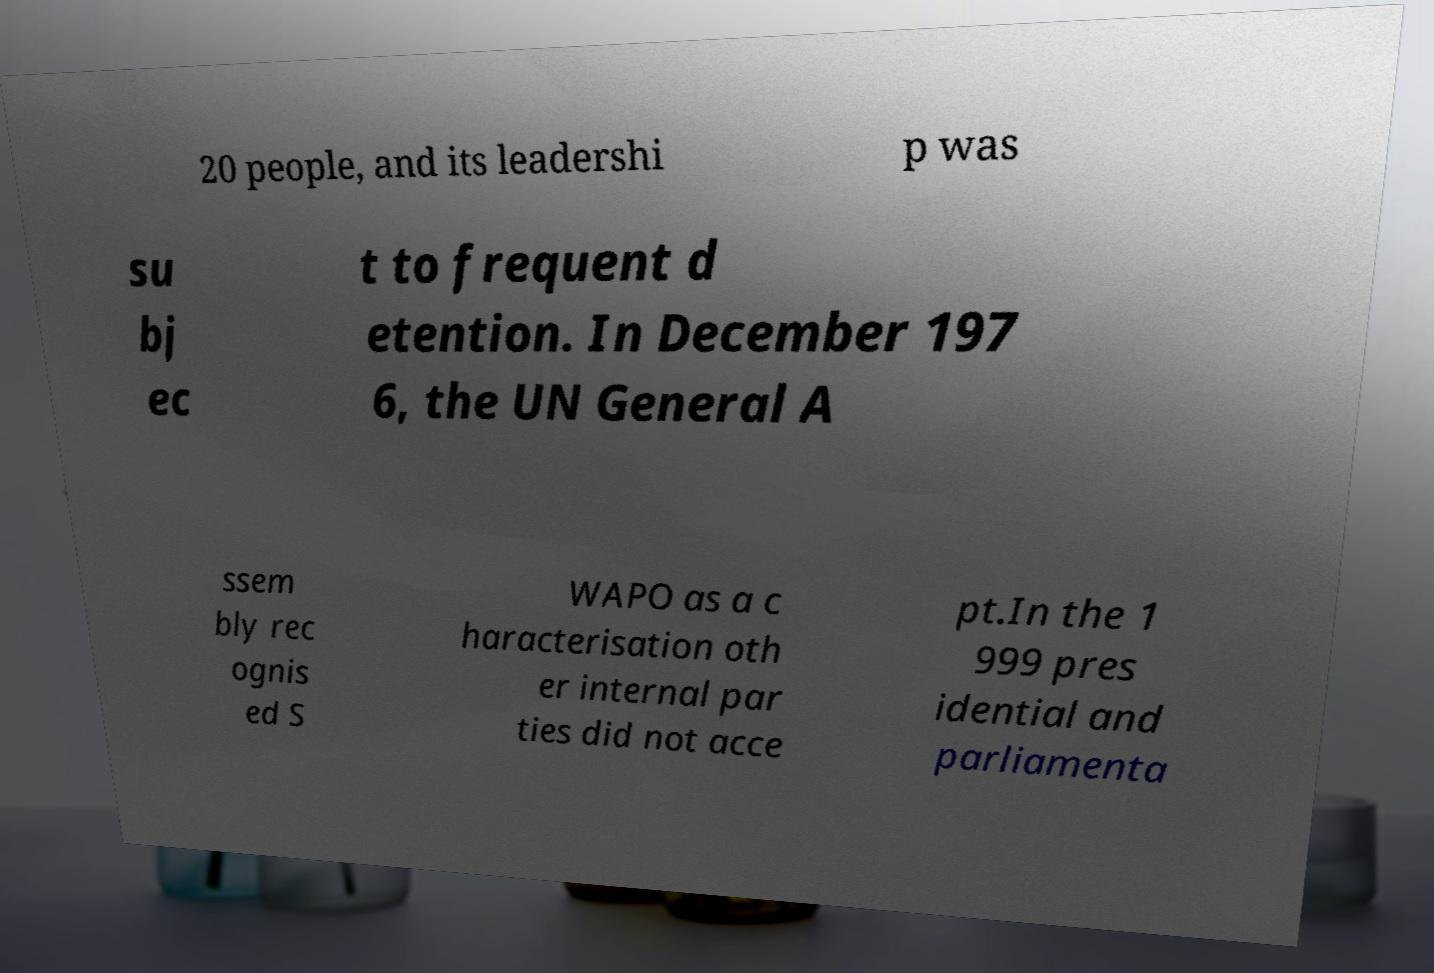For documentation purposes, I need the text within this image transcribed. Could you provide that? 20 people, and its leadershi p was su bj ec t to frequent d etention. In December 197 6, the UN General A ssem bly rec ognis ed S WAPO as a c haracterisation oth er internal par ties did not acce pt.In the 1 999 pres idential and parliamenta 